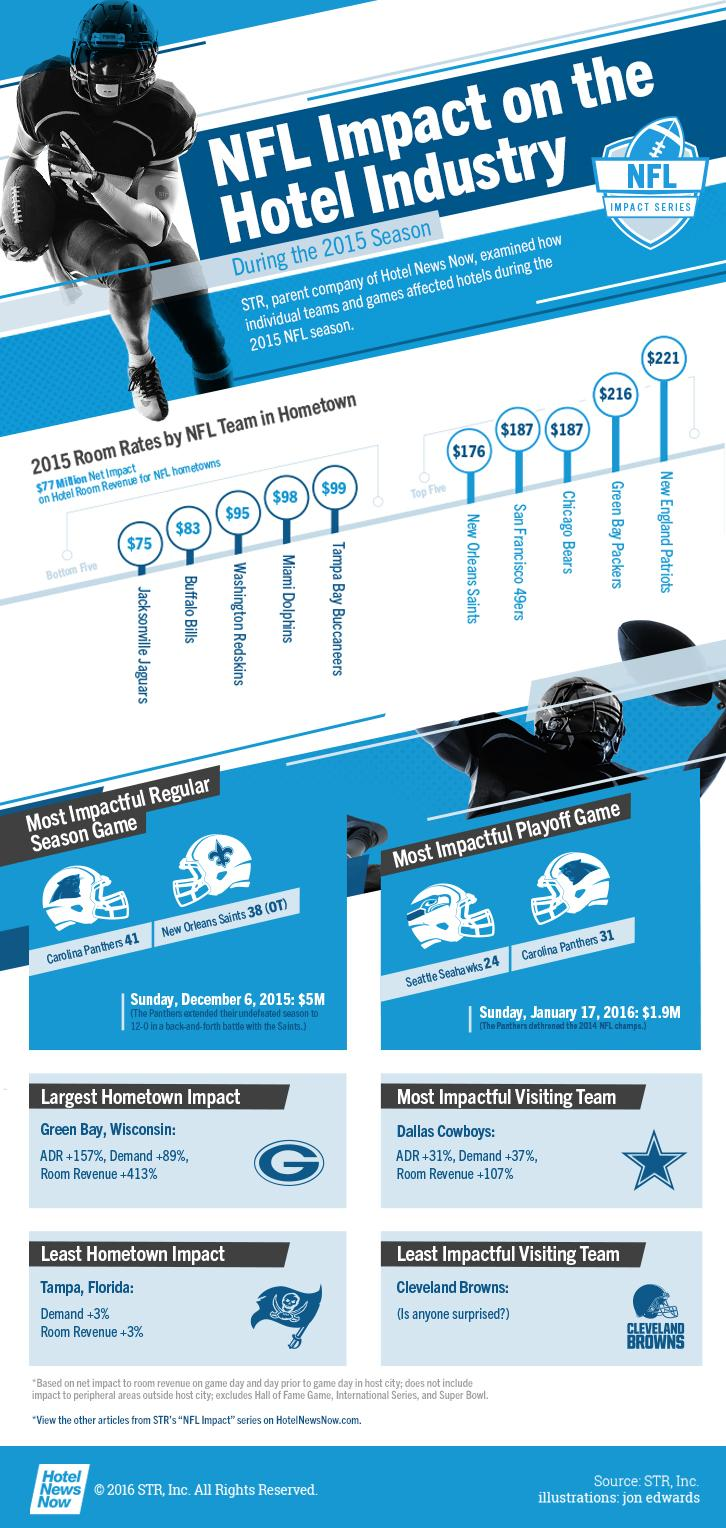Draw attention to some important aspects in this diagram. During the most impactful regular season game, the revenue reached a staggering $5 million. The Miami Dolphins ranked fourth among the bottom five teams in terms of hotel room revenue. The revenue generated from the most impactful playoff game was $1.9 million. According to the top 5 teams in terms of hotel room revenue, Chicago Bears came in third place. Among the bottom 5 teams in terms of hotel room revenue, the Washington Redskins placed third. 